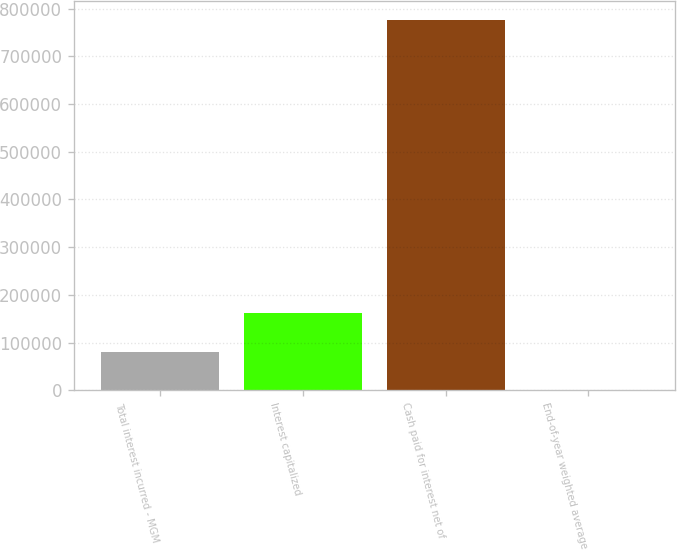<chart> <loc_0><loc_0><loc_500><loc_500><bar_chart><fcel>Total interest incurred - MGM<fcel>Interest capitalized<fcel>Cash paid for interest net of<fcel>End-of-year weighted average<nl><fcel>80878.6<fcel>161751<fcel>776540<fcel>5.9<nl></chart> 